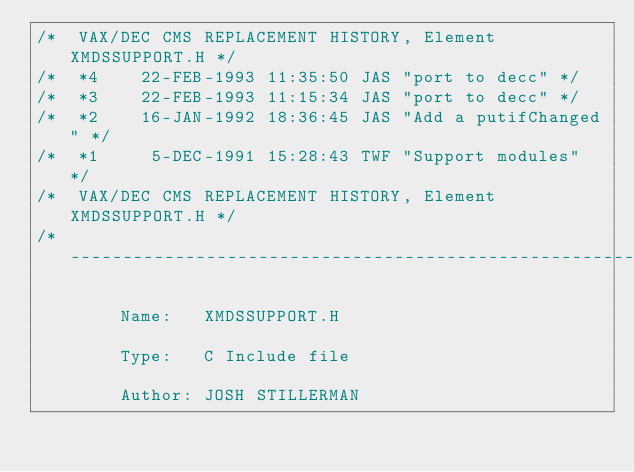Convert code to text. <code><loc_0><loc_0><loc_500><loc_500><_C_>/*  VAX/DEC CMS REPLACEMENT HISTORY, Element XMDSSUPPORT.H */
/*  *4    22-FEB-1993 11:35:50 JAS "port to decc" */
/*  *3    22-FEB-1993 11:15:34 JAS "port to decc" */
/*  *2    16-JAN-1992 18:36:45 JAS "Add a putifChanged" */
/*  *1     5-DEC-1991 15:28:43 TWF "Support modules" */
/*  VAX/DEC CMS REPLACEMENT HISTORY, Element XMDSSUPPORT.H */
/*------------------------------------------------------------------------------

		Name:   XMDSSUPPORT.H

		Type:   C Include file

		Author:	JOSH STILLERMAN
</code> 